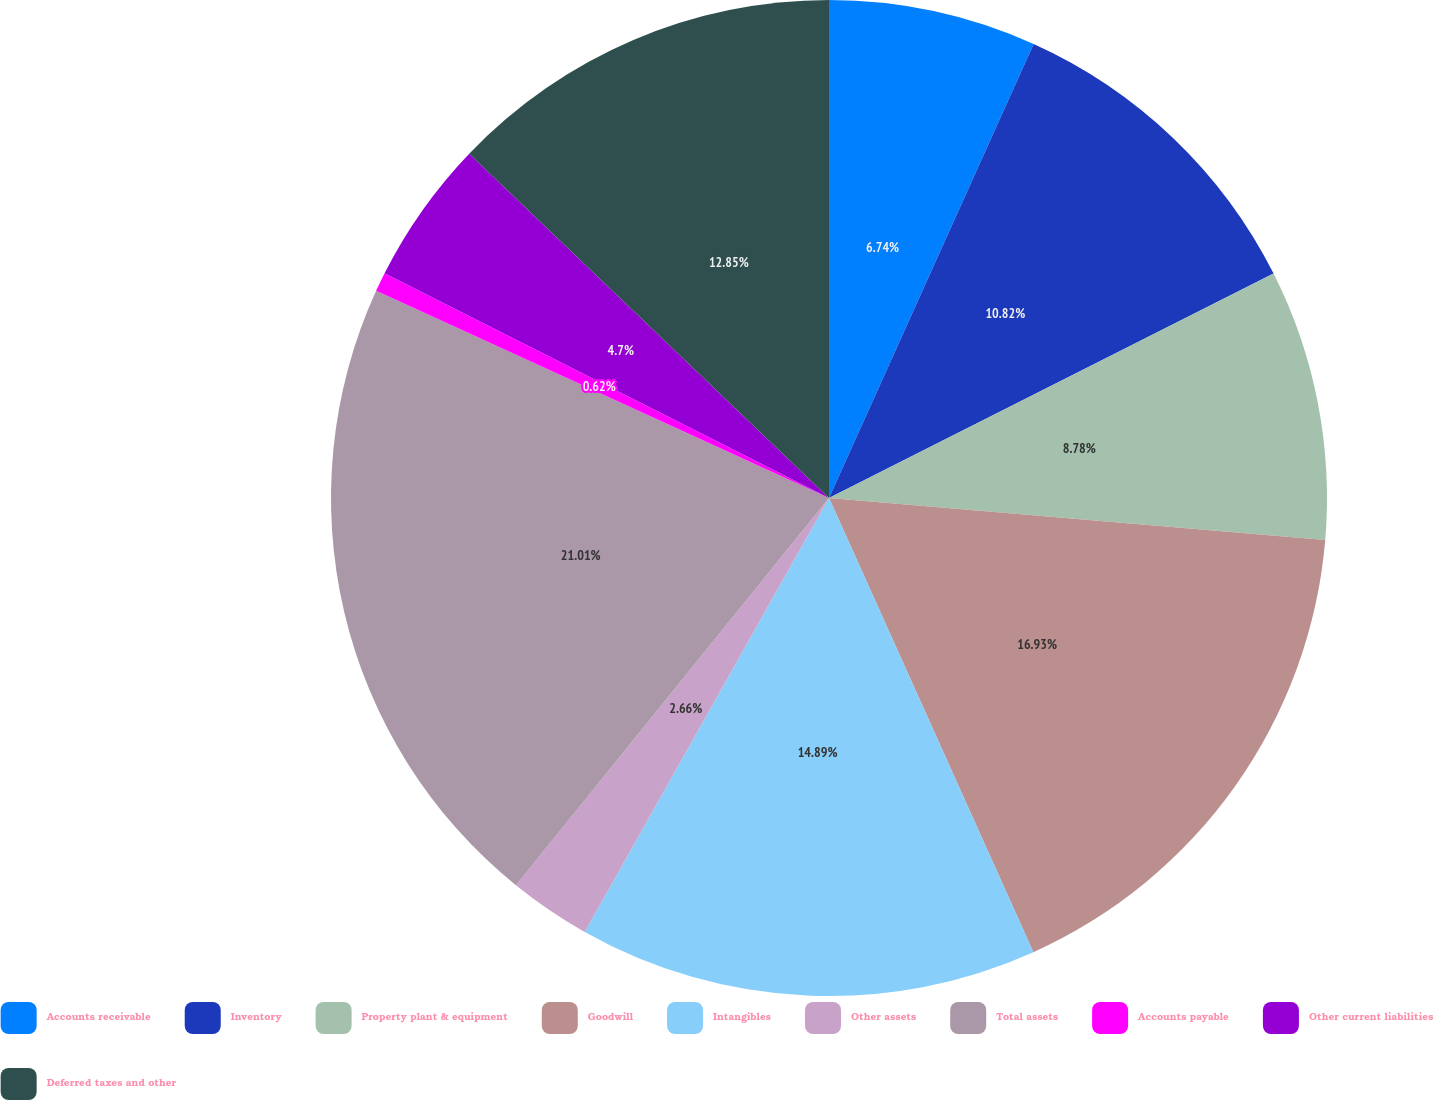Convert chart. <chart><loc_0><loc_0><loc_500><loc_500><pie_chart><fcel>Accounts receivable<fcel>Inventory<fcel>Property plant & equipment<fcel>Goodwill<fcel>Intangibles<fcel>Other assets<fcel>Total assets<fcel>Accounts payable<fcel>Other current liabilities<fcel>Deferred taxes and other<nl><fcel>6.74%<fcel>10.82%<fcel>8.78%<fcel>16.93%<fcel>14.89%<fcel>2.66%<fcel>21.01%<fcel>0.62%<fcel>4.7%<fcel>12.85%<nl></chart> 